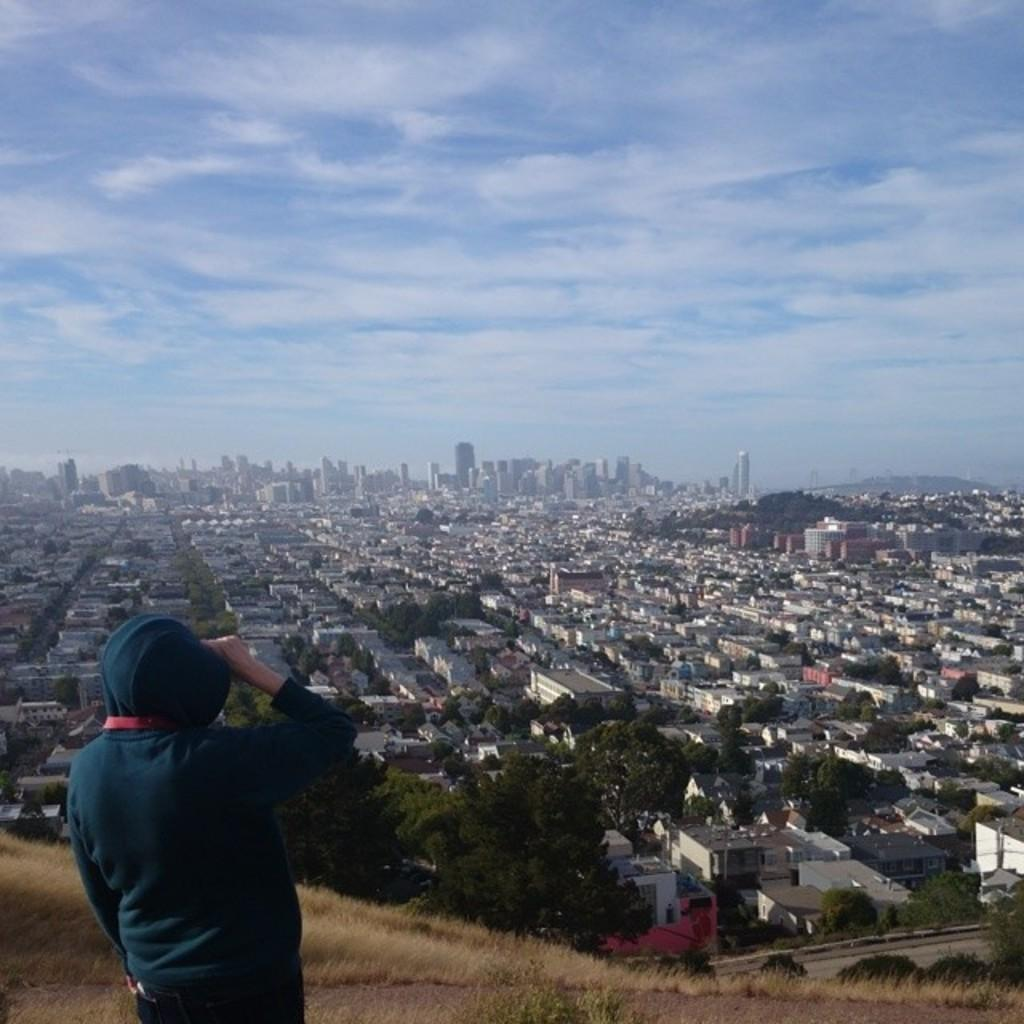What is the weather like in the image? The sky is cloudy in the image. What type of structures can be seen in the image? There are buildings in the image. What type of vegetation is present in the image? There are trees in the image. Who or what is present in the image? There is a person in the image. What is the purpose of the stretch in the image? There is no stretch present in the image, so it cannot have a purpose. 